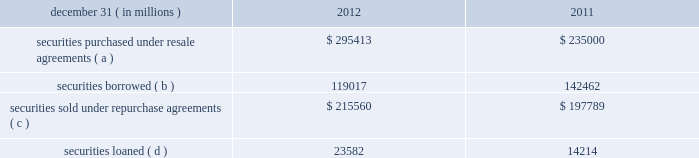Jpmorgan chase & co./2012 annual report 249 note 13 2013 securities financing activities jpmorgan chase enters into resale agreements , repurchase agreements , securities borrowed transactions and securities loaned transactions ( collectively , 201csecurities financing agreements 201d ) primarily to finance the firm 2019s inventory positions , acquire securities to cover short positions , accommodate customers 2019 financing needs , and settle other securities obligations .
Securities financing agreements are treated as collateralized financings on the firm 2019s consolidated balance sheets .
Resale and repurchase agreements are generally carried at the amounts at which the securities will be subsequently sold or repurchased , plus accrued interest .
Securities borrowed and securities loaned transactions are generally carried at the amount of cash collateral advanced or received .
Where appropriate under applicable accounting guidance , resale and repurchase agreements with the same counterparty are reported on a net basis .
Fees received and paid in connection with securities financing agreements are recorded in interest income and interest expense , respectively .
The firm has elected the fair value option for certain securities financing agreements .
For further information regarding the fair value option , see note 4 on pages 214 2013 216 of this annual report .
The securities financing agreements for which the fair value option has been elected are reported within securities purchased under resale agreements ; securities loaned or sold under repurchase agreements ; and securities borrowed on the consolidated balance sheets .
Generally , for agreements carried at fair value , current-period interest accruals are recorded within interest income and interest expense , with changes in fair value reported in principal transactions revenue .
However , for financial instruments containing embedded derivatives that would be separately accounted for in accordance with accounting guidance for hybrid instruments , all changes in fair value , including any interest elements , are reported in principal transactions revenue .
The table details the firm 2019s securities financing agreements , all of which are accounted for as collateralized financings during the periods presented .
December 31 , ( in millions ) 2012 2011 securities purchased under resale agreements ( a ) $ 295413 $ 235000 securities borrowed ( b ) 119017 142462 securities sold under repurchase agreements ( c ) $ 215560 $ 197789 securities loaned ( d ) 23582 14214 ( a ) at december 31 , 2012 and 2011 , included resale agreements of $ 24.3 billion and $ 22.2 billion , respectively , accounted for at fair value .
( b ) at december 31 , 2012 and 2011 , included securities borrowed of $ 10.2 billion and $ 15.3 billion , respectively , accounted for at fair value .
( c ) at december 31 , 2012 and 2011 , included repurchase agreements of $ 3.9 billion and $ 6.8 billion , respectively , accounted for at fair value .
( d ) at december 31 , 2012 , included securities loaned of $ 457 million accounted for at fair value .
There were no securities loaned accounted for at fair value at december 31 , 2011 .
The amounts reported in the table above were reduced by $ 96.9 billion and $ 115.7 billion at december 31 , 2012 and 2011 , respectively , as a result of agreements in effect that meet the specified conditions for net presentation under applicable accounting guidance .
Jpmorgan chase 2019s policy is to take possession , where possible , of securities purchased under resale agreements and of securities borrowed .
The firm monitors the value of the underlying securities ( primarily g7 government securities , u.s .
Agency securities and agency mbs , and equities ) that it has received from its counterparties and either requests additional collateral or returns a portion of the collateral when appropriate in light of the market value of the underlying securities .
Margin levels are established initially based upon the counterparty and type of collateral and monitored on an ongoing basis to protect against declines in collateral value in the event of default .
Jpmorgan chase typically enters into master netting agreements and other collateral arrangements with its resale agreement and securities borrowed counterparties , which provide for the right to liquidate the purchased or borrowed securities in the event of a customer default .
As a result of the firm 2019s credit risk mitigation practices with respect to resale and securities borrowed agreements as described above , the firm did not hold any reserves for credit impairment with respect to these agreements as of december 31 , 2012 and for further information regarding assets pledged and collateral received in securities financing agreements , see note 30 on pages 315 2013316 of this annual report. .
Jpmorgan chase & co./2012 annual report 249 note 13 2013 securities financing activities jpmorgan chase enters into resale agreements , repurchase agreements , securities borrowed transactions and securities loaned transactions ( collectively , 201csecurities financing agreements 201d ) primarily to finance the firm 2019s inventory positions , acquire securities to cover short positions , accommodate customers 2019 financing needs , and settle other securities obligations .
Securities financing agreements are treated as collateralized financings on the firm 2019s consolidated balance sheets .
Resale and repurchase agreements are generally carried at the amounts at which the securities will be subsequently sold or repurchased , plus accrued interest .
Securities borrowed and securities loaned transactions are generally carried at the amount of cash collateral advanced or received .
Where appropriate under applicable accounting guidance , resale and repurchase agreements with the same counterparty are reported on a net basis .
Fees received and paid in connection with securities financing agreements are recorded in interest income and interest expense , respectively .
The firm has elected the fair value option for certain securities financing agreements .
For further information regarding the fair value option , see note 4 on pages 214 2013 216 of this annual report .
The securities financing agreements for which the fair value option has been elected are reported within securities purchased under resale agreements ; securities loaned or sold under repurchase agreements ; and securities borrowed on the consolidated balance sheets .
Generally , for agreements carried at fair value , current-period interest accruals are recorded within interest income and interest expense , with changes in fair value reported in principal transactions revenue .
However , for financial instruments containing embedded derivatives that would be separately accounted for in accordance with accounting guidance for hybrid instruments , all changes in fair value , including any interest elements , are reported in principal transactions revenue .
The following table details the firm 2019s securities financing agreements , all of which are accounted for as collateralized financings during the periods presented .
December 31 , ( in millions ) 2012 2011 securities purchased under resale agreements ( a ) $ 295413 $ 235000 securities borrowed ( b ) 119017 142462 securities sold under repurchase agreements ( c ) $ 215560 $ 197789 securities loaned ( d ) 23582 14214 ( a ) at december 31 , 2012 and 2011 , included resale agreements of $ 24.3 billion and $ 22.2 billion , respectively , accounted for at fair value .
( b ) at december 31 , 2012 and 2011 , included securities borrowed of $ 10.2 billion and $ 15.3 billion , respectively , accounted for at fair value .
( c ) at december 31 , 2012 and 2011 , included repurchase agreements of $ 3.9 billion and $ 6.8 billion , respectively , accounted for at fair value .
( d ) at december 31 , 2012 , included securities loaned of $ 457 million accounted for at fair value .
There were no securities loaned accounted for at fair value at december 31 , 2011 .
The amounts reported in the table above were reduced by $ 96.9 billion and $ 115.7 billion at december 31 , 2012 and 2011 , respectively , as a result of agreements in effect that meet the specified conditions for net presentation under applicable accounting guidance .
Jpmorgan chase 2019s policy is to take possession , where possible , of securities purchased under resale agreements and of securities borrowed .
The firm monitors the value of the underlying securities ( primarily g7 government securities , u.s .
Agency securities and agency mbs , and equities ) that it has received from its counterparties and either requests additional collateral or returns a portion of the collateral when appropriate in light of the market value of the underlying securities .
Margin levels are established initially based upon the counterparty and type of collateral and monitored on an ongoing basis to protect against declines in collateral value in the event of default .
Jpmorgan chase typically enters into master netting agreements and other collateral arrangements with its resale agreement and securities borrowed counterparties , which provide for the right to liquidate the purchased or borrowed securities in the event of a customer default .
As a result of the firm 2019s credit risk mitigation practices with respect to resale and securities borrowed agreements as described above , the firm did not hold any reserves for credit impairment with respect to these agreements as of december 31 , 2012 and for further information regarding assets pledged and collateral received in securities financing agreements , see note 30 on pages 315 2013316 of this annual report. .
At december 31 , 2012 , what is the amount of securities accounted for on the cost basis? 
Computations: ((119017 / 1000) - 10.2)
Answer: 108.817. Jpmorgan chase & co./2012 annual report 249 note 13 2013 securities financing activities jpmorgan chase enters into resale agreements , repurchase agreements , securities borrowed transactions and securities loaned transactions ( collectively , 201csecurities financing agreements 201d ) primarily to finance the firm 2019s inventory positions , acquire securities to cover short positions , accommodate customers 2019 financing needs , and settle other securities obligations .
Securities financing agreements are treated as collateralized financings on the firm 2019s consolidated balance sheets .
Resale and repurchase agreements are generally carried at the amounts at which the securities will be subsequently sold or repurchased , plus accrued interest .
Securities borrowed and securities loaned transactions are generally carried at the amount of cash collateral advanced or received .
Where appropriate under applicable accounting guidance , resale and repurchase agreements with the same counterparty are reported on a net basis .
Fees received and paid in connection with securities financing agreements are recorded in interest income and interest expense , respectively .
The firm has elected the fair value option for certain securities financing agreements .
For further information regarding the fair value option , see note 4 on pages 214 2013 216 of this annual report .
The securities financing agreements for which the fair value option has been elected are reported within securities purchased under resale agreements ; securities loaned or sold under repurchase agreements ; and securities borrowed on the consolidated balance sheets .
Generally , for agreements carried at fair value , current-period interest accruals are recorded within interest income and interest expense , with changes in fair value reported in principal transactions revenue .
However , for financial instruments containing embedded derivatives that would be separately accounted for in accordance with accounting guidance for hybrid instruments , all changes in fair value , including any interest elements , are reported in principal transactions revenue .
The table details the firm 2019s securities financing agreements , all of which are accounted for as collateralized financings during the periods presented .
December 31 , ( in millions ) 2012 2011 securities purchased under resale agreements ( a ) $ 295413 $ 235000 securities borrowed ( b ) 119017 142462 securities sold under repurchase agreements ( c ) $ 215560 $ 197789 securities loaned ( d ) 23582 14214 ( a ) at december 31 , 2012 and 2011 , included resale agreements of $ 24.3 billion and $ 22.2 billion , respectively , accounted for at fair value .
( b ) at december 31 , 2012 and 2011 , included securities borrowed of $ 10.2 billion and $ 15.3 billion , respectively , accounted for at fair value .
( c ) at december 31 , 2012 and 2011 , included repurchase agreements of $ 3.9 billion and $ 6.8 billion , respectively , accounted for at fair value .
( d ) at december 31 , 2012 , included securities loaned of $ 457 million accounted for at fair value .
There were no securities loaned accounted for at fair value at december 31 , 2011 .
The amounts reported in the table above were reduced by $ 96.9 billion and $ 115.7 billion at december 31 , 2012 and 2011 , respectively , as a result of agreements in effect that meet the specified conditions for net presentation under applicable accounting guidance .
Jpmorgan chase 2019s policy is to take possession , where possible , of securities purchased under resale agreements and of securities borrowed .
The firm monitors the value of the underlying securities ( primarily g7 government securities , u.s .
Agency securities and agency mbs , and equities ) that it has received from its counterparties and either requests additional collateral or returns a portion of the collateral when appropriate in light of the market value of the underlying securities .
Margin levels are established initially based upon the counterparty and type of collateral and monitored on an ongoing basis to protect against declines in collateral value in the event of default .
Jpmorgan chase typically enters into master netting agreements and other collateral arrangements with its resale agreement and securities borrowed counterparties , which provide for the right to liquidate the purchased or borrowed securities in the event of a customer default .
As a result of the firm 2019s credit risk mitigation practices with respect to resale and securities borrowed agreements as described above , the firm did not hold any reserves for credit impairment with respect to these agreements as of december 31 , 2012 and for further information regarding assets pledged and collateral received in securities financing agreements , see note 30 on pages 315 2013316 of this annual report. .
Jpmorgan chase & co./2012 annual report 249 note 13 2013 securities financing activities jpmorgan chase enters into resale agreements , repurchase agreements , securities borrowed transactions and securities loaned transactions ( collectively , 201csecurities financing agreements 201d ) primarily to finance the firm 2019s inventory positions , acquire securities to cover short positions , accommodate customers 2019 financing needs , and settle other securities obligations .
Securities financing agreements are treated as collateralized financings on the firm 2019s consolidated balance sheets .
Resale and repurchase agreements are generally carried at the amounts at which the securities will be subsequently sold or repurchased , plus accrued interest .
Securities borrowed and securities loaned transactions are generally carried at the amount of cash collateral advanced or received .
Where appropriate under applicable accounting guidance , resale and repurchase agreements with the same counterparty are reported on a net basis .
Fees received and paid in connection with securities financing agreements are recorded in interest income and interest expense , respectively .
The firm has elected the fair value option for certain securities financing agreements .
For further information regarding the fair value option , see note 4 on pages 214 2013 216 of this annual report .
The securities financing agreements for which the fair value option has been elected are reported within securities purchased under resale agreements ; securities loaned or sold under repurchase agreements ; and securities borrowed on the consolidated balance sheets .
Generally , for agreements carried at fair value , current-period interest accruals are recorded within interest income and interest expense , with changes in fair value reported in principal transactions revenue .
However , for financial instruments containing embedded derivatives that would be separately accounted for in accordance with accounting guidance for hybrid instruments , all changes in fair value , including any interest elements , are reported in principal transactions revenue .
The following table details the firm 2019s securities financing agreements , all of which are accounted for as collateralized financings during the periods presented .
December 31 , ( in millions ) 2012 2011 securities purchased under resale agreements ( a ) $ 295413 $ 235000 securities borrowed ( b ) 119017 142462 securities sold under repurchase agreements ( c ) $ 215560 $ 197789 securities loaned ( d ) 23582 14214 ( a ) at december 31 , 2012 and 2011 , included resale agreements of $ 24.3 billion and $ 22.2 billion , respectively , accounted for at fair value .
( b ) at december 31 , 2012 and 2011 , included securities borrowed of $ 10.2 billion and $ 15.3 billion , respectively , accounted for at fair value .
( c ) at december 31 , 2012 and 2011 , included repurchase agreements of $ 3.9 billion and $ 6.8 billion , respectively , accounted for at fair value .
( d ) at december 31 , 2012 , included securities loaned of $ 457 million accounted for at fair value .
There were no securities loaned accounted for at fair value at december 31 , 2011 .
The amounts reported in the table above were reduced by $ 96.9 billion and $ 115.7 billion at december 31 , 2012 and 2011 , respectively , as a result of agreements in effect that meet the specified conditions for net presentation under applicable accounting guidance .
Jpmorgan chase 2019s policy is to take possession , where possible , of securities purchased under resale agreements and of securities borrowed .
The firm monitors the value of the underlying securities ( primarily g7 government securities , u.s .
Agency securities and agency mbs , and equities ) that it has received from its counterparties and either requests additional collateral or returns a portion of the collateral when appropriate in light of the market value of the underlying securities .
Margin levels are established initially based upon the counterparty and type of collateral and monitored on an ongoing basis to protect against declines in collateral value in the event of default .
Jpmorgan chase typically enters into master netting agreements and other collateral arrangements with its resale agreement and securities borrowed counterparties , which provide for the right to liquidate the purchased or borrowed securities in the event of a customer default .
As a result of the firm 2019s credit risk mitigation practices with respect to resale and securities borrowed agreements as described above , the firm did not hold any reserves for credit impairment with respect to these agreements as of december 31 , 2012 and for further information regarding assets pledged and collateral received in securities financing agreements , see note 30 on pages 315 2013316 of this annual report. .
In 2012 what was the percent of the securities loaned included in the accounted for at fair value? 
Computations: (457 / 23582)
Answer: 0.01938. 